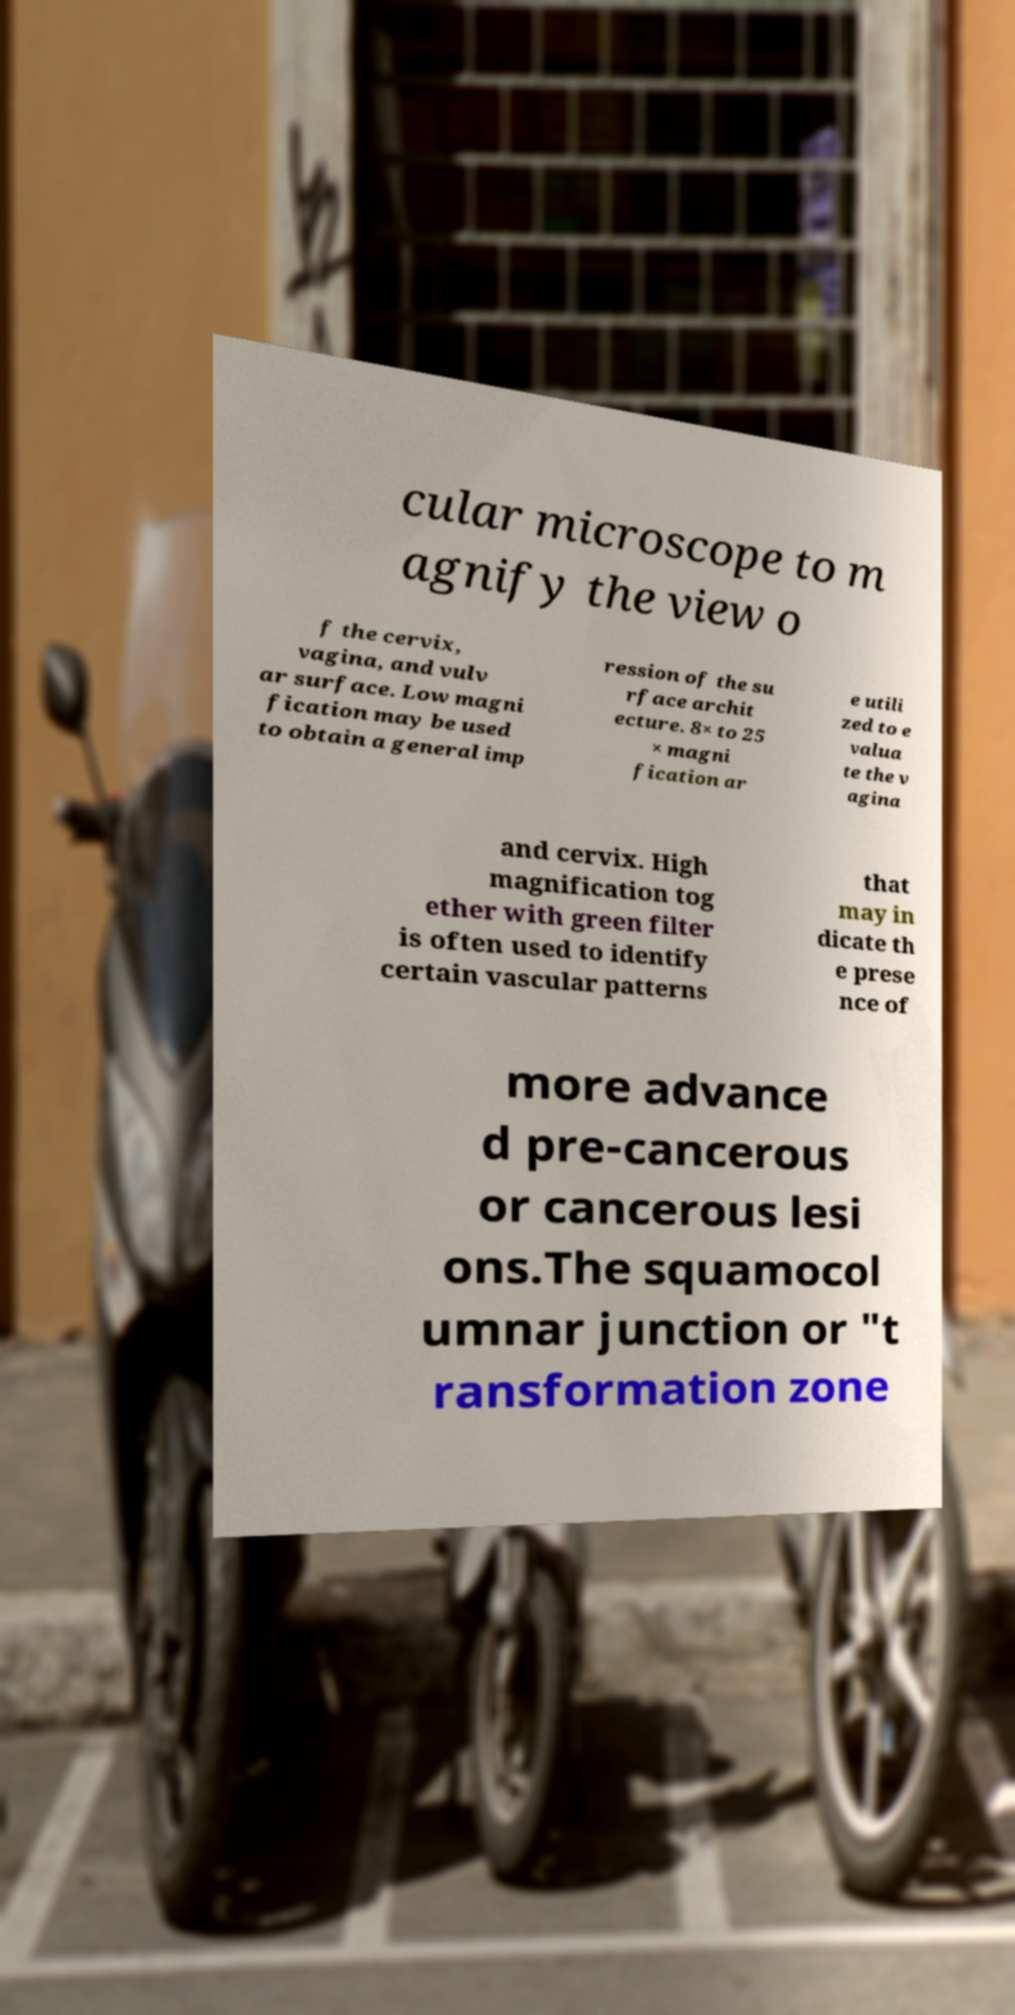Can you accurately transcribe the text from the provided image for me? cular microscope to m agnify the view o f the cervix, vagina, and vulv ar surface. Low magni fication may be used to obtain a general imp ression of the su rface archit ecture. 8× to 25 × magni fication ar e utili zed to e valua te the v agina and cervix. High magnification tog ether with green filter is often used to identify certain vascular patterns that may in dicate th e prese nce of more advance d pre-cancerous or cancerous lesi ons.The squamocol umnar junction or "t ransformation zone 